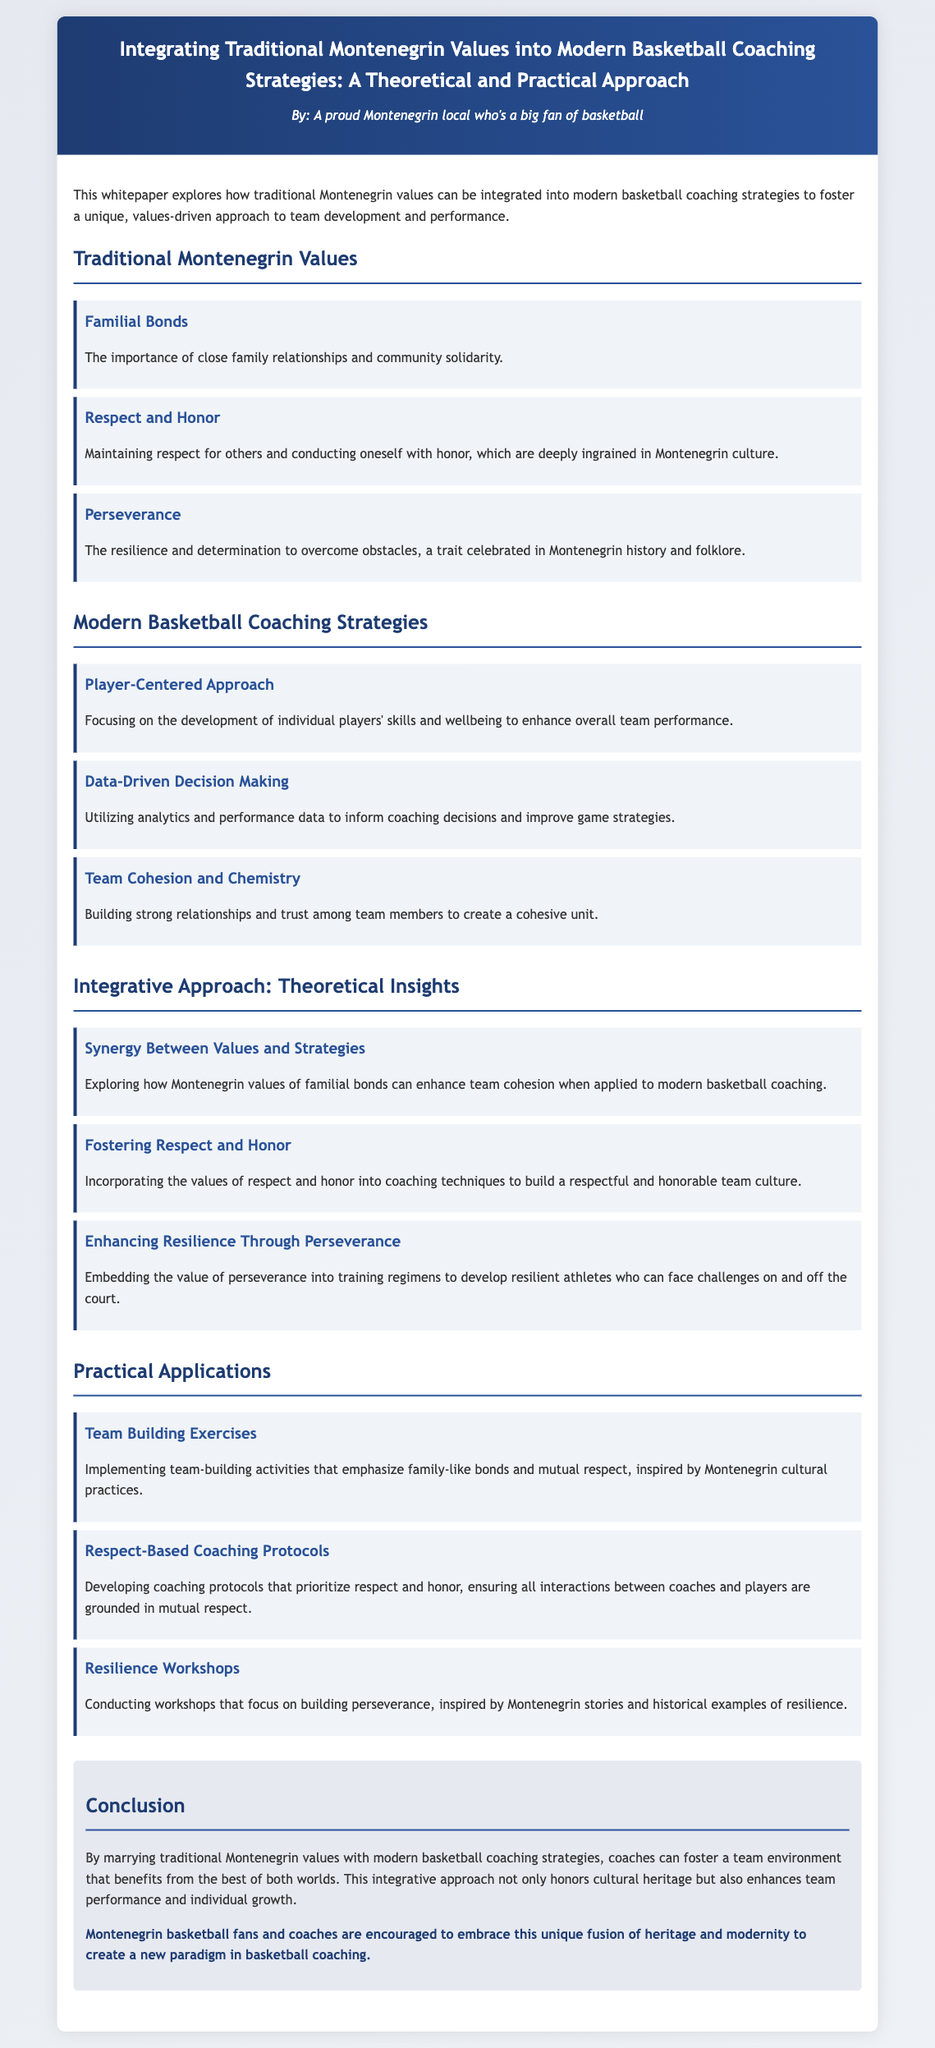What are the three traditional Montenegrin values mentioned? The three traditional Montenegrin values are familial bonds, respect and honor, and perseverance.
Answer: Familial bonds, respect and honor, perseverance What is the focus of the player-centered approach? The player-centered approach focuses on the development of individual players' skills and wellbeing.
Answer: Development of individual players' skills and wellbeing What concept explores the synergy between values and strategies? The concept that explores this synergy is titled "Synergy Between Values and Strategies."
Answer: Synergy Between Values and Strategies What type of team-building activities are suggested in the practical applications? The team-building activities suggested emphasize family-like bonds and mutual respect.
Answer: Family-like bonds and mutual respect How are resilience workshops intended to be structured? Resilience workshops are structured to focus on building perseverance inspired by Montenegrin stories.
Answer: Building perseverance inspired by Montenegrin stories What is a key benefit of integrating Montenegrin values into basketball coaching? A key benefit is fostering a team environment that enhances team performance and individual growth.
Answer: Enhances team performance and individual growth Which cultural aspect is mentioned as a source for practical applications? The cultural aspect mentioned is Montenegrin cultural practices.
Answer: Montenegrin cultural practices 